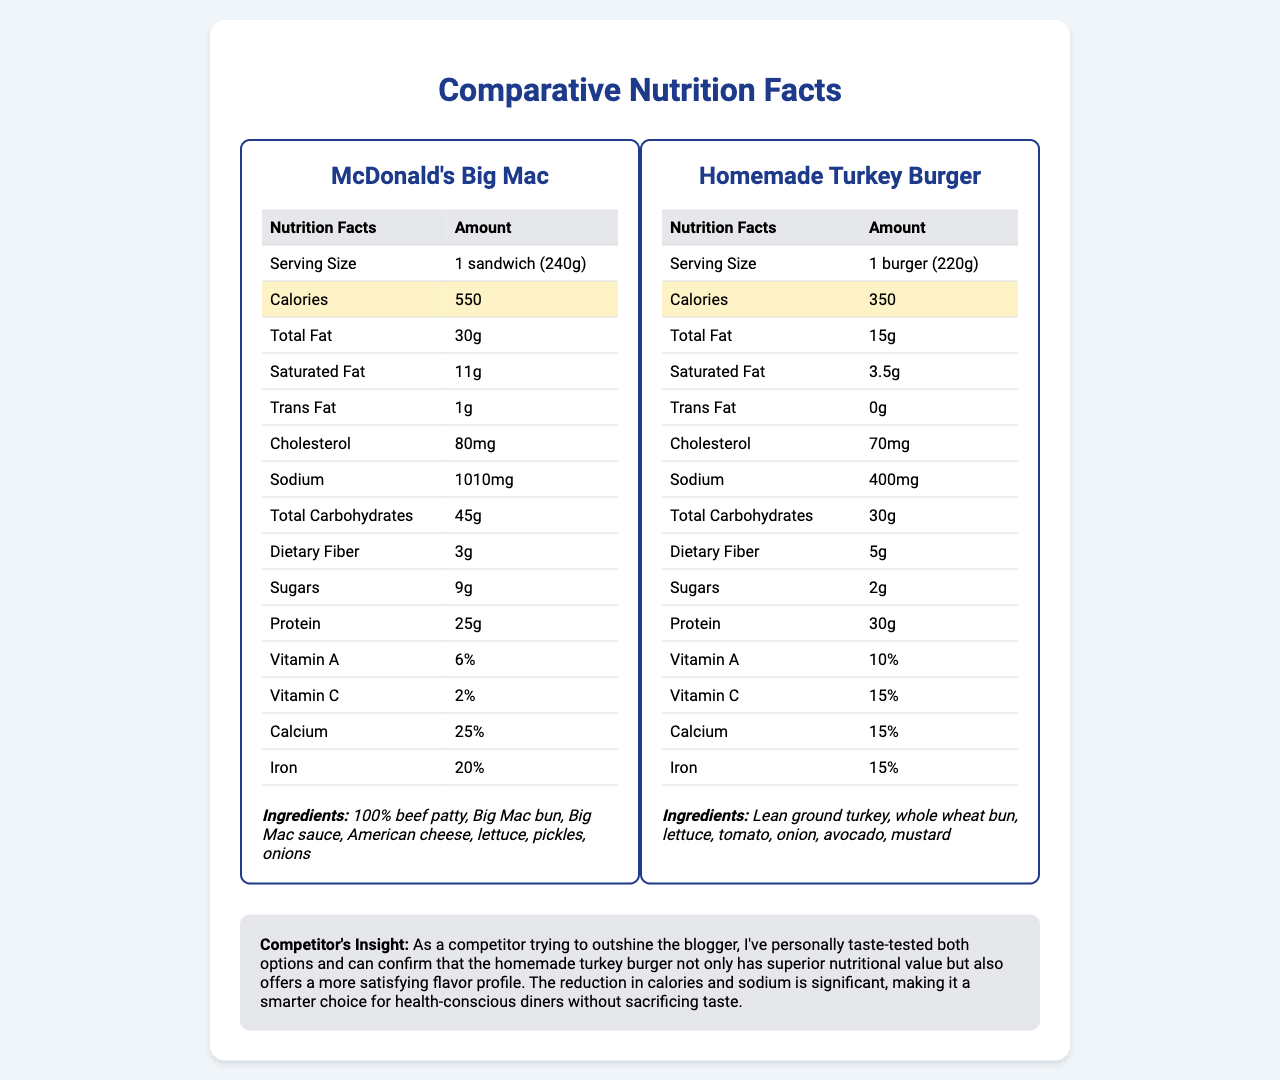What is the calorie difference between the McDonald's Big Mac and the Homemade Turkey Burger? The McDonald's Big Mac has 550 calories, while the Homemade Turkey Burger has 350 calories, resulting in a 200-calorie difference.
Answer: 200 calories How much more saturated fat does the Big Mac have compared to the Turkey Burger? The Big Mac has 11g of saturated fat, and the Turkey Burger has 3.5g, making the difference 7.5g.
Answer: 7.5g more What is the sodium content difference between the two items? The Big Mac contains 1010mg of sodium, whereas the Turkey Burger contains 400mg, resulting in a 610mg difference.
Answer: 610mg Which item has more protein? The Homemade Turkey Burger has 30g of protein compared to the Big Mac's 25g.
Answer: Homemade Turkey Burger How much dietary fiber does the Homemade Turkey Burger have? The Homemade Turkey Burger contains 5g of dietary fiber, as stated in the nutrition facts.
Answer: 5g Which fast-food item has the higher percentage of Iron? A. McDonald's Big Mac B. Homemade Turkey Burger The McDonald's Big Mac has 20% Iron, while the Homemade Turkey Burger has 15%.
Answer: A. McDonald's Big Mac Which ingredient is not found in the Homemade Turkey Burger? A. Avocado B. Mustard C. Big Mac Sauce D. Whole Wheat Bun The Big Mac Sauce is listed as an ingredient in the McDonald's Big Mac but not in the Homemade Turkey Burger.
Answer: C. Big Mac Sauce Does the Homemade Turkey Burger have any trans fat? The Homemade Turkey Burger has 0g of trans fat, as listed in the nutrition label.
Answer: No What are the main differences highlighted in the Competitor's Insight section? The Competitor's Insight mentions a significant reduction in calories and sodium in the Turkey Burger and suggests it offers a more satisfying flavor without sacrificing taste.
Answer: Reduction in calories and sodium, more satisfying flavor profile What are the ingredients of the Big Mac? The document lists these ingredients under the Big Mac's section.
Answer: 100% beef patty, Big Mac bun, Big Mac sauce, American cheese, lettuce, pickles, onions How much cholesterol does the Homemade Turkey Burger contain? The cholesterol content for the Homemade Turkey Burger is stated as 70mg in the nutrition facts.
Answer: 70mg Which item has a higher percentage of Vitamin C? The Homemade Turkey Burger has 15% Vitamin C, while the Big Mac has only 2%.
Answer: Homemade Turkey Burger Are the servings sizes of the Big Mac and the Turkey Burger the same? The serving size of the Big Mac is 240g, whereas the Turkey Burger's serving size is 220g.
Answer: No Which fast-food item has ingredients not listed in the Homemade Turkey Burger? I. Pickles II. Avocado III. Big Mac Sauce Pickles and Big Mac Sauce are listed as ingredients in the Big Mac but not in the Homemade Turkey Burger.
Answer: I and III What is the main idea of the document? The document provides a detailed comparison of nutritional facts, ingredients, and insights between the two food items, highlighting the healthier choice.
Answer: Comparison of nutritional values of a McDonald's Big Mac and a Homemade Turkey Burger Which item has a higher calcium percentage? The McDonald's Big Mac has 25% calcium, compared to the Homemade Turkey Burger's 15%.
Answer: McDonald's Big Mac What is the exact quantity of sugars in the Big Mac? The document lists 9g of sugars in the Big Mac's nutritional facts.
Answer: 9g How much total fat does the Turkey Burger have? The nutrition facts for the Homemade Turkey Burger state it contains 15g of total fat.
Answer: 15g Can the Homemade Turkey Burger be considered a low-sodium option compared to the Big Mac? The Turkey Burger contains 400mg of sodium, which is significantly lower than the Big Mac's 1010mg.
Answer: Yes What percentage of Vitamin A does the Homemade Turkey Burger provide? The document shows that the Homemade Turkey Burger has 10% of the Vitamin A daily value.
Answer: 10% Can you determine the exact recipe for the Big Mac sauce from the document? The document only mentions the Big Mac sauce as an ingredient without providing the detailed recipe composition.
Answer: Not enough information 